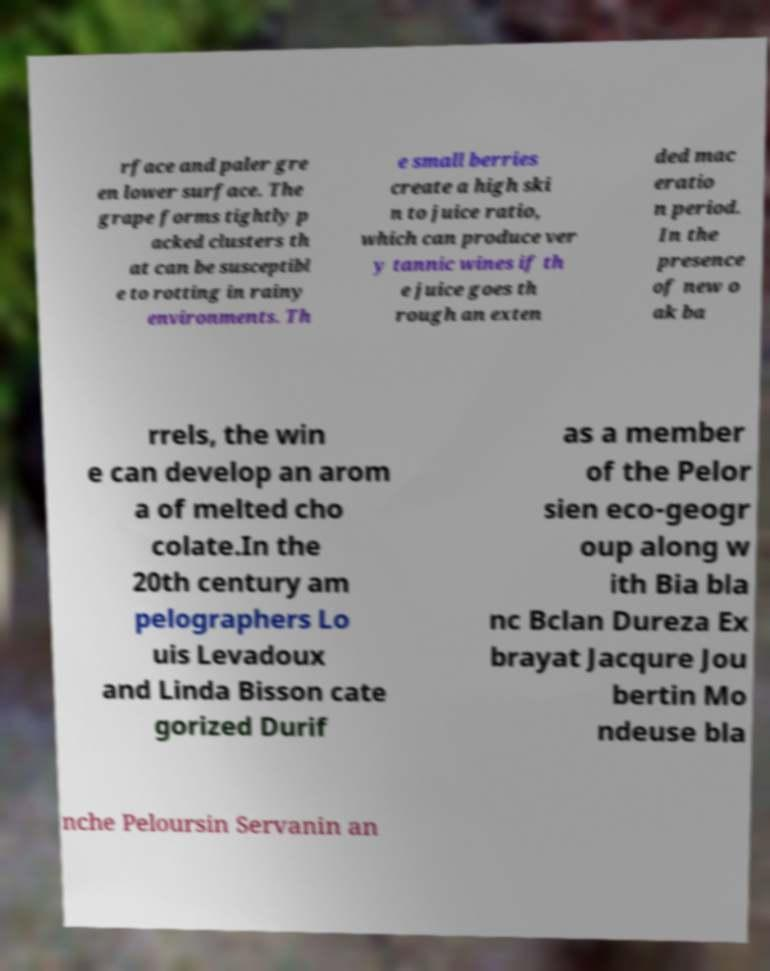Can you read and provide the text displayed in the image?This photo seems to have some interesting text. Can you extract and type it out for me? rface and paler gre en lower surface. The grape forms tightly p acked clusters th at can be susceptibl e to rotting in rainy environments. Th e small berries create a high ski n to juice ratio, which can produce ver y tannic wines if th e juice goes th rough an exten ded mac eratio n period. In the presence of new o ak ba rrels, the win e can develop an arom a of melted cho colate.In the 20th century am pelographers Lo uis Levadoux and Linda Bisson cate gorized Durif as a member of the Pelor sien eco-geogr oup along w ith Bia bla nc Bclan Dureza Ex brayat Jacqure Jou bertin Mo ndeuse bla nche Peloursin Servanin an 